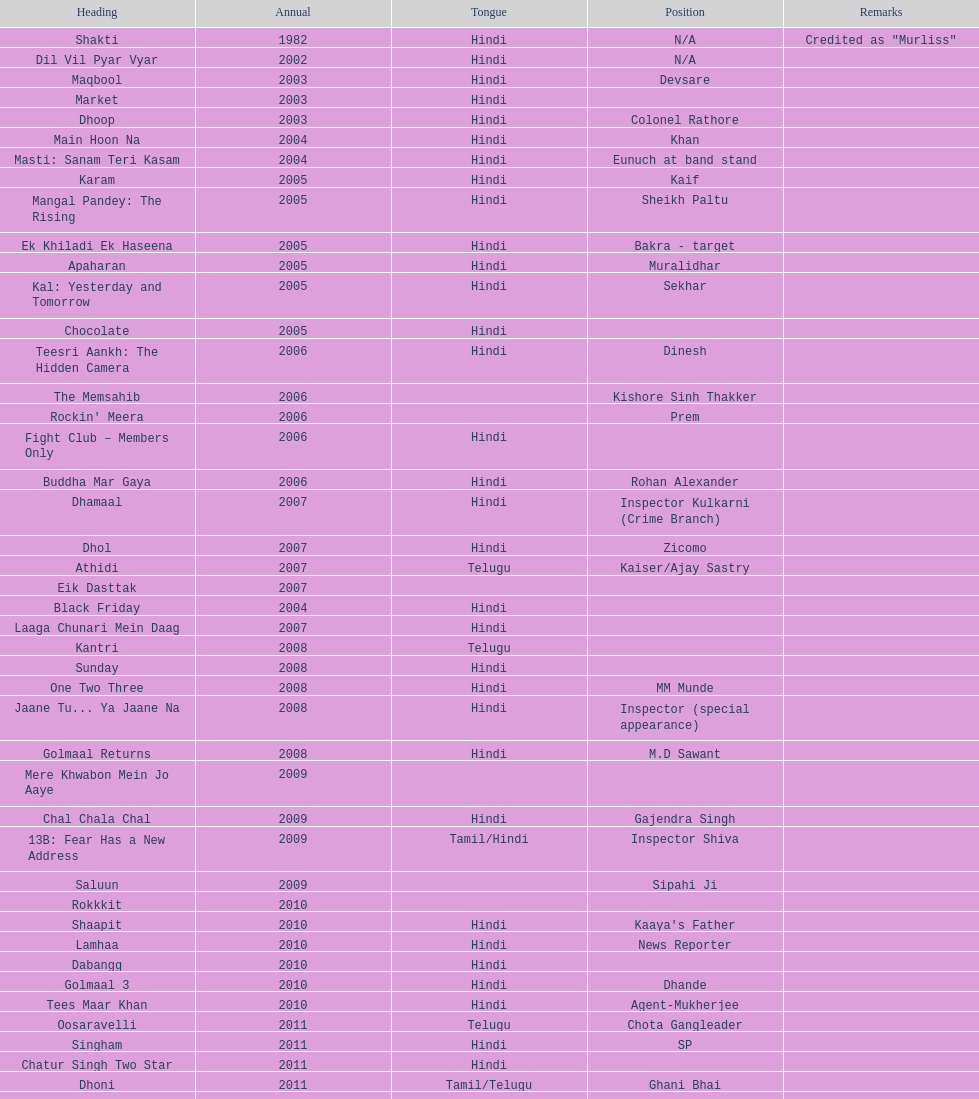What is the first language after hindi Telugu. 